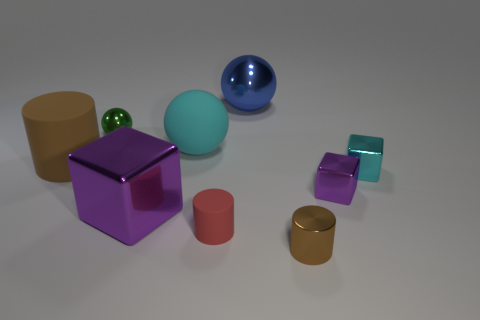Subtract all big purple cubes. How many cubes are left? 2 Subtract all yellow balls. How many brown cylinders are left? 2 Subtract 1 spheres. How many spheres are left? 2 Add 1 big gray shiny objects. How many objects exist? 10 Subtract all green blocks. Subtract all red cylinders. How many blocks are left? 3 Subtract all spheres. How many objects are left? 6 Subtract all large matte objects. Subtract all small metal spheres. How many objects are left? 6 Add 9 small green metal spheres. How many small green metal spheres are left? 10 Add 1 small gray things. How many small gray things exist? 1 Subtract 2 purple blocks. How many objects are left? 7 